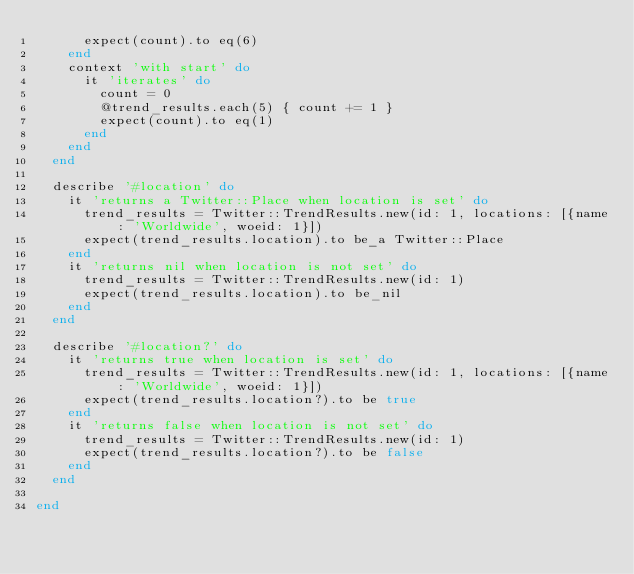<code> <loc_0><loc_0><loc_500><loc_500><_Ruby_>      expect(count).to eq(6)
    end
    context 'with start' do
      it 'iterates' do
        count = 0
        @trend_results.each(5) { count += 1 }
        expect(count).to eq(1)
      end
    end
  end

  describe '#location' do
    it 'returns a Twitter::Place when location is set' do
      trend_results = Twitter::TrendResults.new(id: 1, locations: [{name: 'Worldwide', woeid: 1}])
      expect(trend_results.location).to be_a Twitter::Place
    end
    it 'returns nil when location is not set' do
      trend_results = Twitter::TrendResults.new(id: 1)
      expect(trend_results.location).to be_nil
    end
  end

  describe '#location?' do
    it 'returns true when location is set' do
      trend_results = Twitter::TrendResults.new(id: 1, locations: [{name: 'Worldwide', woeid: 1}])
      expect(trend_results.location?).to be true
    end
    it 'returns false when location is not set' do
      trend_results = Twitter::TrendResults.new(id: 1)
      expect(trend_results.location?).to be false
    end
  end

end
</code> 